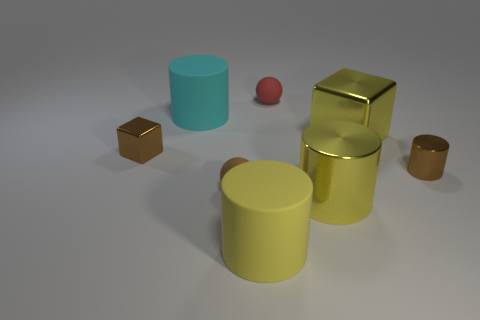Add 1 large rubber cylinders. How many objects exist? 9 Subtract all blocks. How many objects are left? 6 Add 5 tiny brown metal blocks. How many tiny brown metal blocks are left? 6 Add 2 large cyan cylinders. How many large cyan cylinders exist? 3 Subtract 1 red spheres. How many objects are left? 7 Subtract all small spheres. Subtract all small brown blocks. How many objects are left? 5 